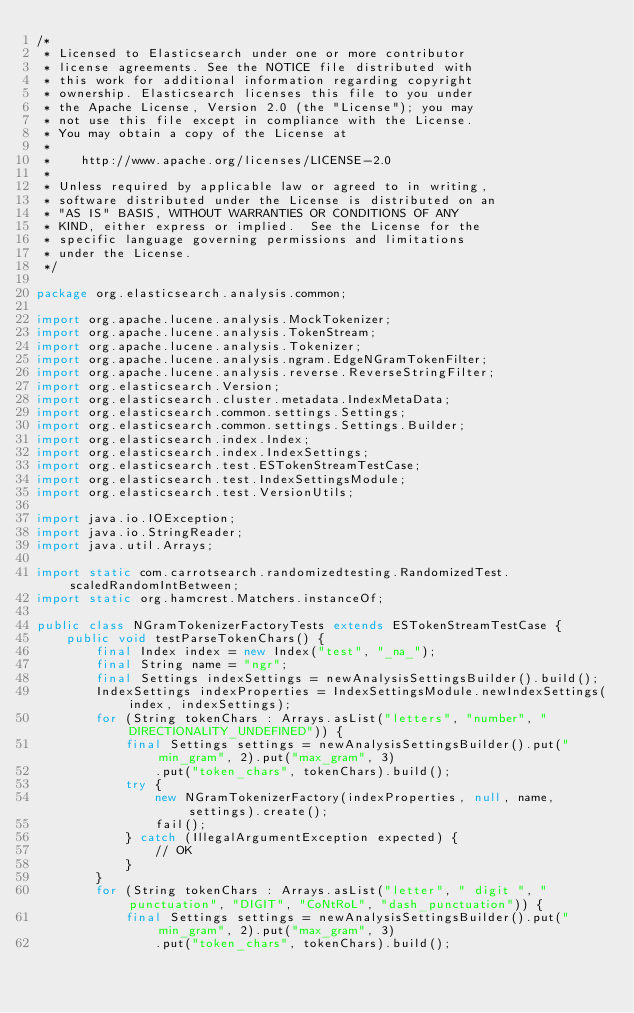<code> <loc_0><loc_0><loc_500><loc_500><_Java_>/*
 * Licensed to Elasticsearch under one or more contributor
 * license agreements. See the NOTICE file distributed with
 * this work for additional information regarding copyright
 * ownership. Elasticsearch licenses this file to you under
 * the Apache License, Version 2.0 (the "License"); you may
 * not use this file except in compliance with the License.
 * You may obtain a copy of the License at
 *
 *    http://www.apache.org/licenses/LICENSE-2.0
 *
 * Unless required by applicable law or agreed to in writing,
 * software distributed under the License is distributed on an
 * "AS IS" BASIS, WITHOUT WARRANTIES OR CONDITIONS OF ANY
 * KIND, either express or implied.  See the License for the
 * specific language governing permissions and limitations
 * under the License.
 */

package org.elasticsearch.analysis.common;

import org.apache.lucene.analysis.MockTokenizer;
import org.apache.lucene.analysis.TokenStream;
import org.apache.lucene.analysis.Tokenizer;
import org.apache.lucene.analysis.ngram.EdgeNGramTokenFilter;
import org.apache.lucene.analysis.reverse.ReverseStringFilter;
import org.elasticsearch.Version;
import org.elasticsearch.cluster.metadata.IndexMetaData;
import org.elasticsearch.common.settings.Settings;
import org.elasticsearch.common.settings.Settings.Builder;
import org.elasticsearch.index.Index;
import org.elasticsearch.index.IndexSettings;
import org.elasticsearch.test.ESTokenStreamTestCase;
import org.elasticsearch.test.IndexSettingsModule;
import org.elasticsearch.test.VersionUtils;

import java.io.IOException;
import java.io.StringReader;
import java.util.Arrays;

import static com.carrotsearch.randomizedtesting.RandomizedTest.scaledRandomIntBetween;
import static org.hamcrest.Matchers.instanceOf;

public class NGramTokenizerFactoryTests extends ESTokenStreamTestCase {
    public void testParseTokenChars() {
        final Index index = new Index("test", "_na_");
        final String name = "ngr";
        final Settings indexSettings = newAnalysisSettingsBuilder().build();
        IndexSettings indexProperties = IndexSettingsModule.newIndexSettings(index, indexSettings);
        for (String tokenChars : Arrays.asList("letters", "number", "DIRECTIONALITY_UNDEFINED")) {
            final Settings settings = newAnalysisSettingsBuilder().put("min_gram", 2).put("max_gram", 3)
                .put("token_chars", tokenChars).build();
            try {
                new NGramTokenizerFactory(indexProperties, null, name, settings).create();
                fail();
            } catch (IllegalArgumentException expected) {
                // OK
            }
        }
        for (String tokenChars : Arrays.asList("letter", " digit ", "punctuation", "DIGIT", "CoNtRoL", "dash_punctuation")) {
            final Settings settings = newAnalysisSettingsBuilder().put("min_gram", 2).put("max_gram", 3)
                .put("token_chars", tokenChars).build();</code> 